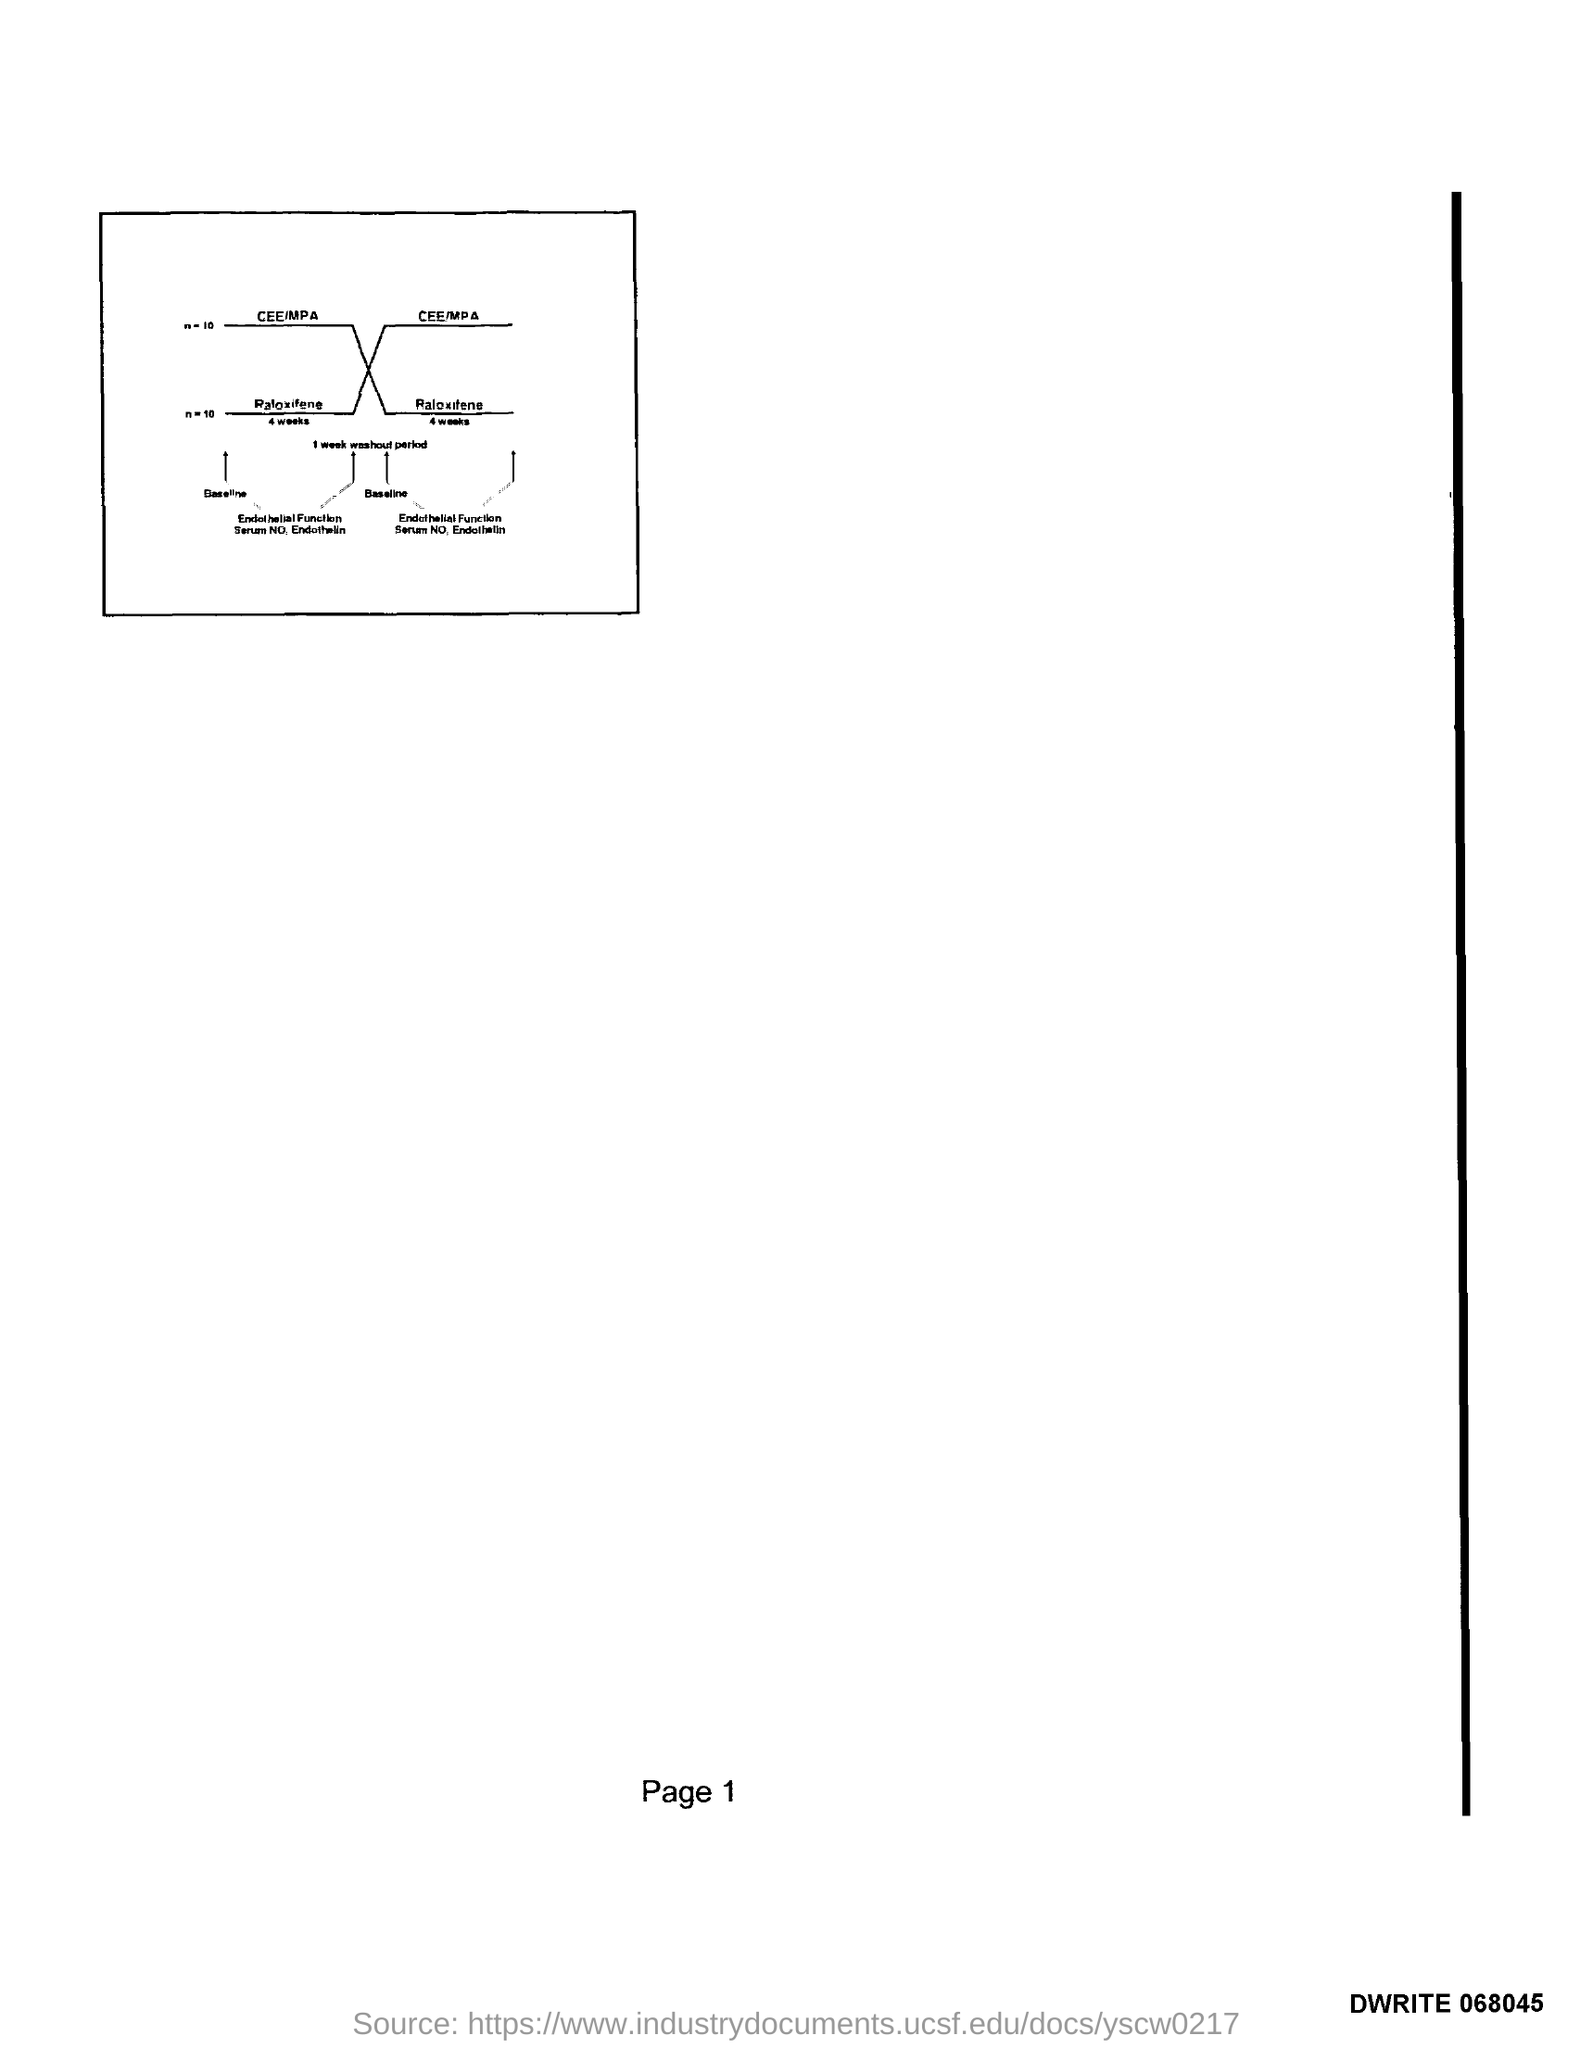Give some essential details in this illustration. I am listing the page numbers from 1 to... 